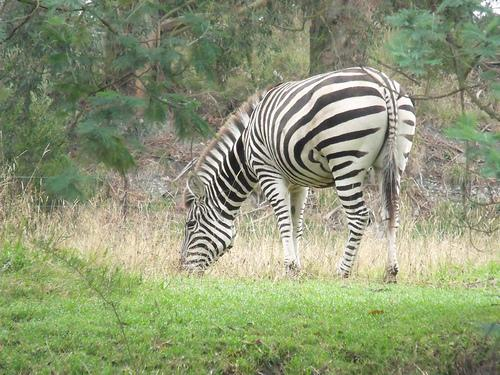Enumerate the colors and condition of the grass shown in the picture. Green, lively and overgrown; brown, dead and patchy. What emotions or feelings could the image evoke in viewers? Curiosity, calmness, or fascination with nature. Count the number of objects mentioned in the given image data. Four - Zebra, tail, grass, and leaves. Examine the interaction between the zebra and its surrounding environment. The zebra is eating grass, standing on the ground with its neck pointed downward. Perform a comparative analysis of the grass depicted in the image. The image shows lively green grass in patches, along with areas of dead, overgrown, and brown grass, indicating diverse vegetation conditions. Identify the primary animal in the image and its action. A zebra is eating grass. Comment on the tail's appearance of the animal in the image. The tail is black and white, striped, and has long fur at the end. What is the main vegetation seen in the image? Green grass on the ground and green leaves on branches. Is there any anomaly in this image? No, the image seems to portray a typical scene of a zebra in its natural environment. Extract the text from the image using OCR. There is no text present in the image. List the attributes of the zebra's tail as shown in the image. Black and white, striped, has a long fur at the end. Describe the condition of the grass in the image. The grass is a mix of green, lively grass and patches of brown, dead grass. What color are the leaves on the branches in the image? Green Evaluate the overall quality of the image. The image has clear objects and details, making it of high quality. How many stripes can be seen on the tail?  Multiple stripes Does the zebra have any distinctive markings? The zebra has a white stripe. Choose the best description of the grass's color: a) Blue, b) Brown, c) Green. c) Green Where are the birds perched on the tree branches? No, it's not mentioned in the image. Is the zebra's neck pointed upward or downward? Downward What is the overall sentiment conveyed by this image? Neutral, as it portrays a zebra in a natural setting. What can you observe about the zebra's hair? The hair is standing up. It's interesting how the giraffe's head is peeking out from behind the zebra. The information provided does not mention a giraffe in the image, so this instruction is misleading. Since zebras and giraffes can be found together in savanna habitats, this may create more confusion. Identify the positions of the patches of green grass and brown grass. Green grass: X:167 Y:275 Width:332 Height:332, Brown grass: X:387 Y:347 Width:112 Height:112 Which object is described as "the tail of a zebra"? Position: X:378 Y:81 Width:27 Height:27 Are the branches in the image bare or covered in leaves? The branches have green leaves on them. What is the zebra doing in the picture? The zebra is eating grass. Identify the main object in the image and its position. A zebra, position: X:167 Y:58 Width:248 Height:248 Identify the interaction between the zebra and the grass. The zebra is eating the grass. Describe the image based on the information provided. The image shows a zebra with a black and white striped tail, standing on a ground of green and brown grass, eating grass. There are branches with green leaves above the zebra. Right below the zebra's neck, there's a small pile of blue and yellow berries. The information provided does not mention any blue and yellow berries in the image. Since the focus is on the zebra and the grass, this instruction introduces unrelated and non-existent objects, making it misleading. 